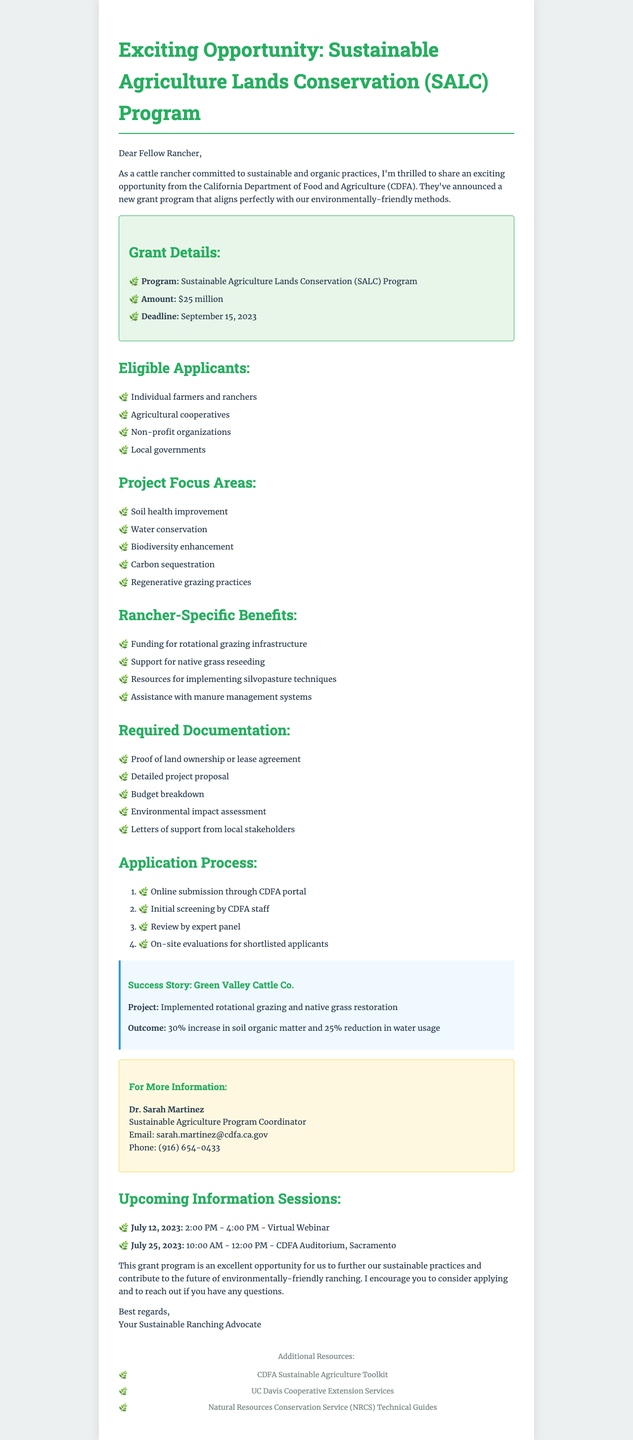What is the name of the grant program? The document mentions the grant program as the Sustainable Agriculture Lands Conservation Program.
Answer: Sustainable Agriculture Lands Conservation Program What is the total amount of the grant? The total grant amount stated in the document is $25 million.
Answer: $25 million When is the application deadline? The document specifies the application deadline as September 15, 2023.
Answer: September 15, 2023 Who is the contact person for this grant? The document lists Dr. Sarah Martinez as the contact person for more information regarding the grant.
Answer: Dr. Sarah Martinez What project focus area involves improving soil health? The document includes soil health improvement as one of the project focus areas.
Answer: Soil health improvement Which type of organizations can apply for the grant? The document lists agricultural cooperatives as one of the eligible applicant types.
Answer: Agricultural cooperatives What benefit does the grant provide specific to ranchers? The document states that the funding can be used for rotational grazing infrastructure as a specific benefit for ranchers.
Answer: Funding for rotational grazing infrastructure How many information sessions are mentioned? The document indicates that there are two upcoming information sessions regarding the grant.
Answer: Two What is the title of the contact person? The document refers to Dr. Sarah Martinez as the Sustainable Agriculture Program Coordinator.
Answer: Sustainable Agriculture Program Coordinator What is the expected outcome of the success story from Green Valley Cattle Co.? The document mentions a 30% increase in soil organic matter as the outcome for the Green Valley Cattle Co. project.
Answer: 30% increase in soil organic matter 